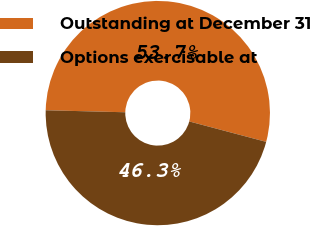<chart> <loc_0><loc_0><loc_500><loc_500><pie_chart><fcel>Outstanding at December 31<fcel>Options exercisable at<nl><fcel>53.73%<fcel>46.27%<nl></chart> 